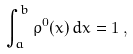<formula> <loc_0><loc_0><loc_500><loc_500>\int _ { a } ^ { b } \rho ^ { 0 } ( x ) \, d x = 1 \, ,</formula> 